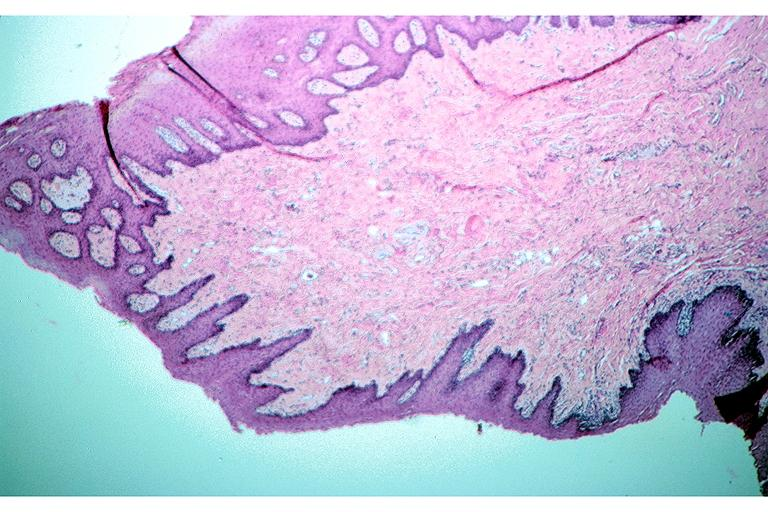what does this image show?
Answer the question using a single word or phrase. Irritation fibroma 